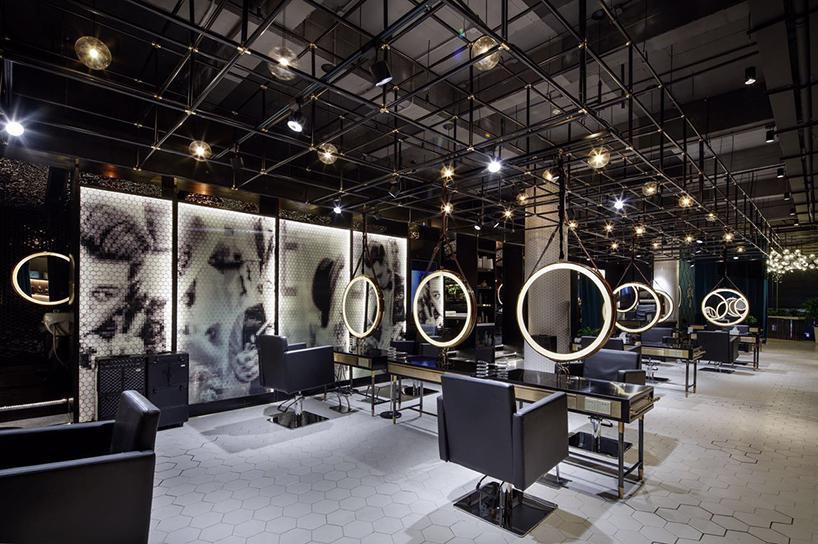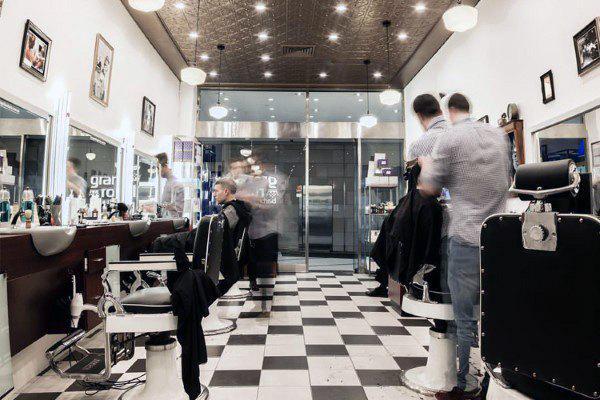The first image is the image on the left, the second image is the image on the right. Evaluate the accuracy of this statement regarding the images: "In at least one image there is a row of three white circles over a glass nail tables.". Is it true? Answer yes or no. Yes. The first image is the image on the left, the second image is the image on the right. Given the left and right images, does the statement "Round mirrors in white frames are suspended in front of dark armchairs from black metal bars, in one image." hold true? Answer yes or no. Yes. 